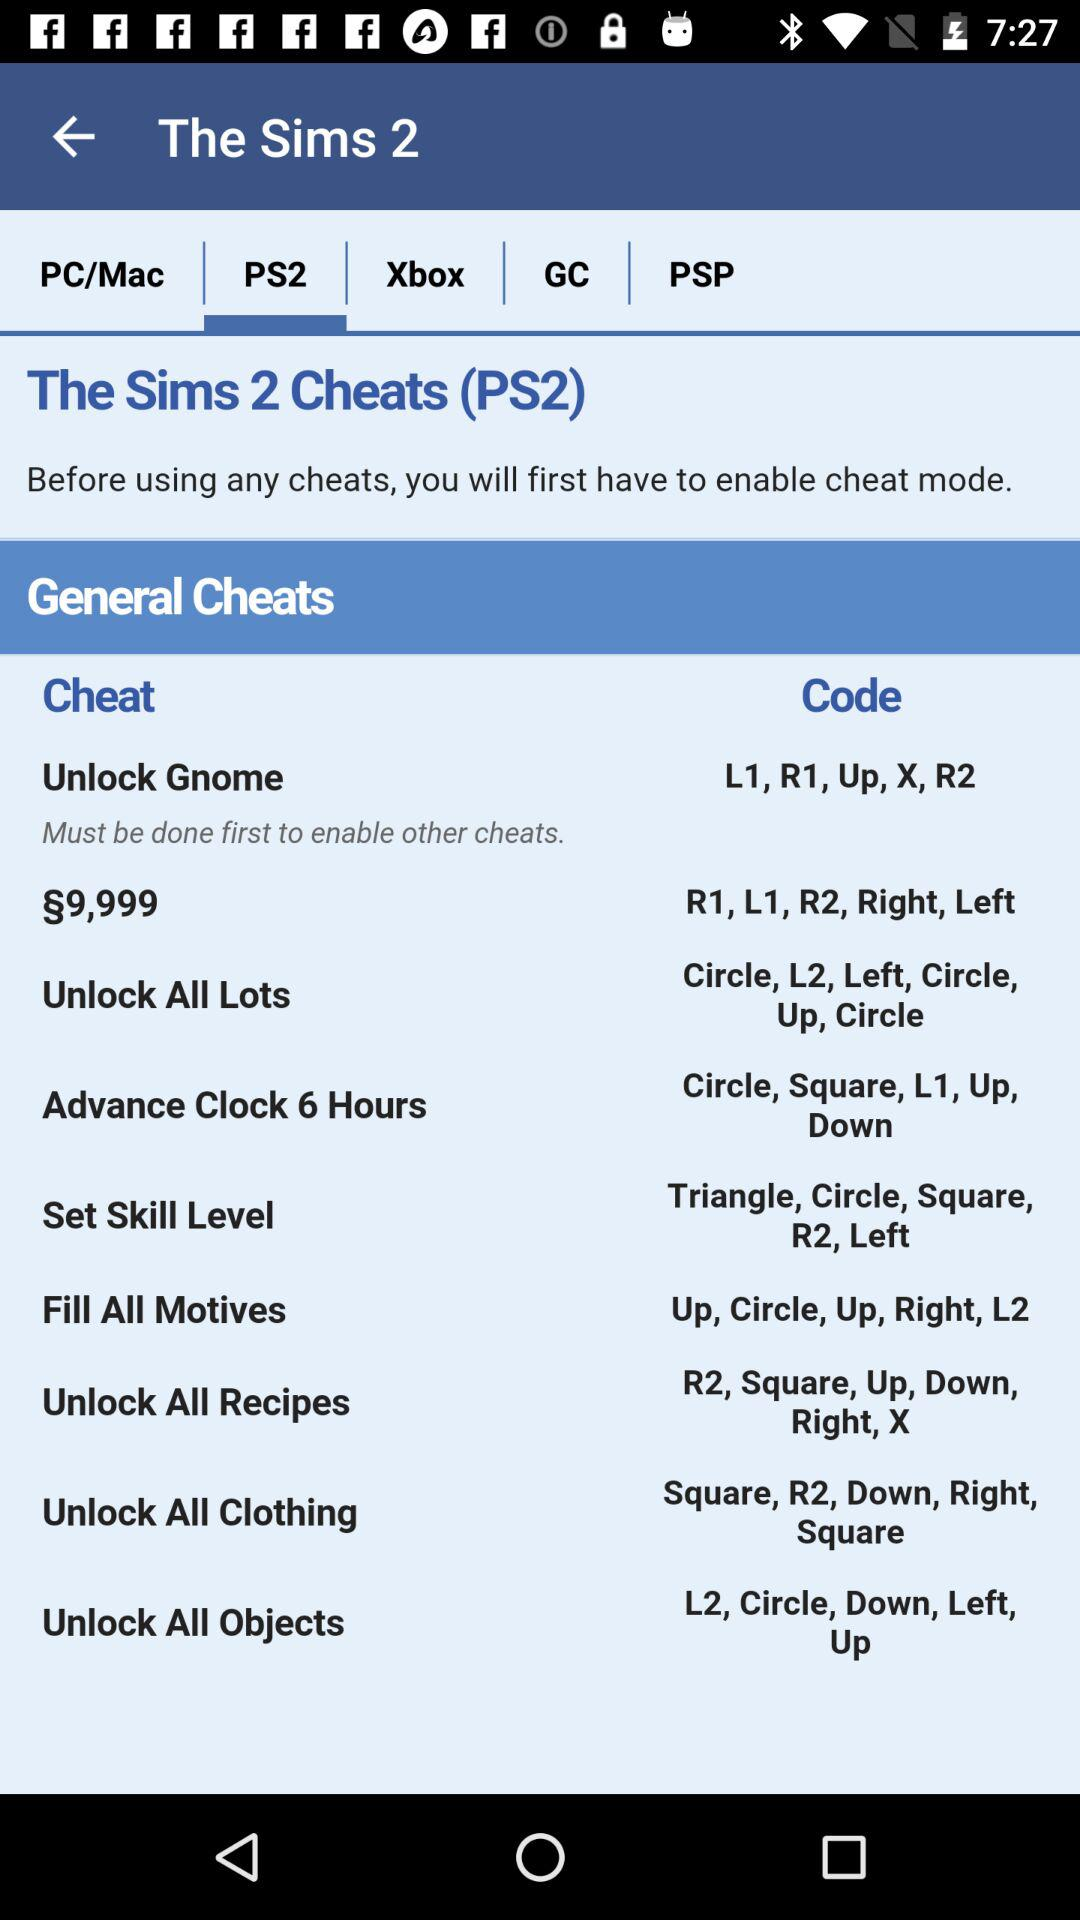What is the code for "Unlock Gnome"? The code is "L1, R1, Up, X, R2". 